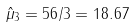Convert formula to latex. <formula><loc_0><loc_0><loc_500><loc_500>\hat { \mu } _ { 3 } = 5 6 / 3 = 1 8 . 6 7</formula> 